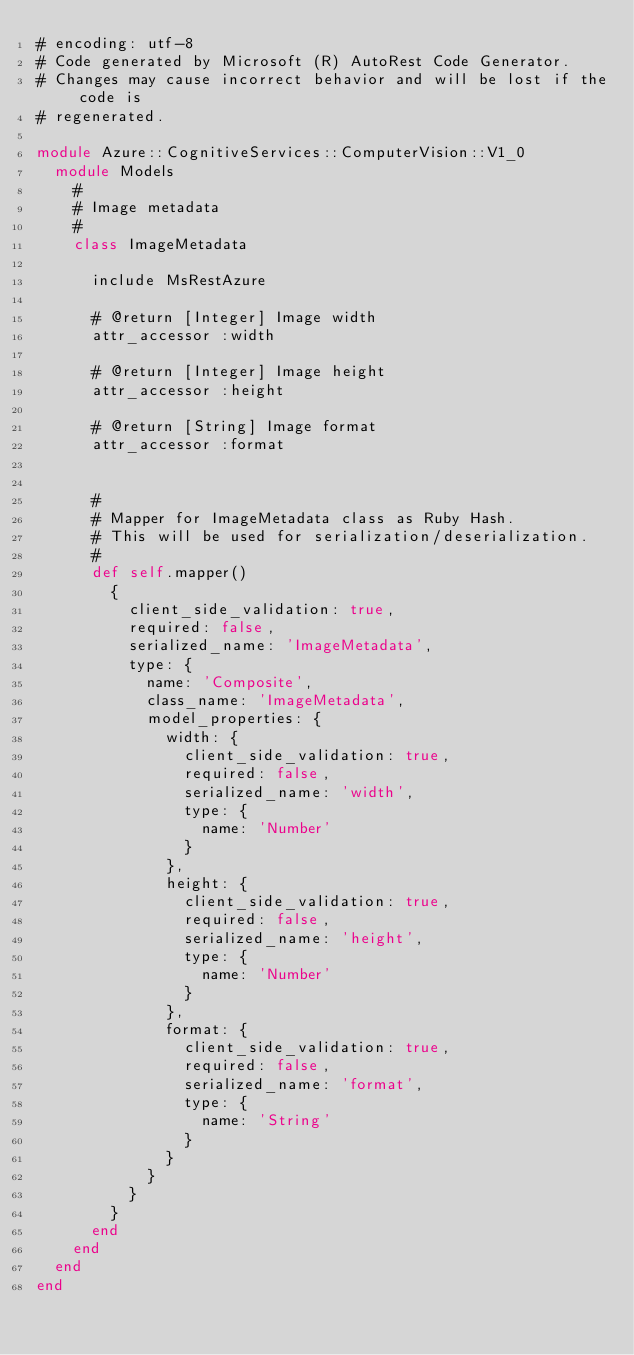Convert code to text. <code><loc_0><loc_0><loc_500><loc_500><_Ruby_># encoding: utf-8
# Code generated by Microsoft (R) AutoRest Code Generator.
# Changes may cause incorrect behavior and will be lost if the code is
# regenerated.

module Azure::CognitiveServices::ComputerVision::V1_0
  module Models
    #
    # Image metadata
    #
    class ImageMetadata

      include MsRestAzure

      # @return [Integer] Image width
      attr_accessor :width

      # @return [Integer] Image height
      attr_accessor :height

      # @return [String] Image format
      attr_accessor :format


      #
      # Mapper for ImageMetadata class as Ruby Hash.
      # This will be used for serialization/deserialization.
      #
      def self.mapper()
        {
          client_side_validation: true,
          required: false,
          serialized_name: 'ImageMetadata',
          type: {
            name: 'Composite',
            class_name: 'ImageMetadata',
            model_properties: {
              width: {
                client_side_validation: true,
                required: false,
                serialized_name: 'width',
                type: {
                  name: 'Number'
                }
              },
              height: {
                client_side_validation: true,
                required: false,
                serialized_name: 'height',
                type: {
                  name: 'Number'
                }
              },
              format: {
                client_side_validation: true,
                required: false,
                serialized_name: 'format',
                type: {
                  name: 'String'
                }
              }
            }
          }
        }
      end
    end
  end
end
</code> 